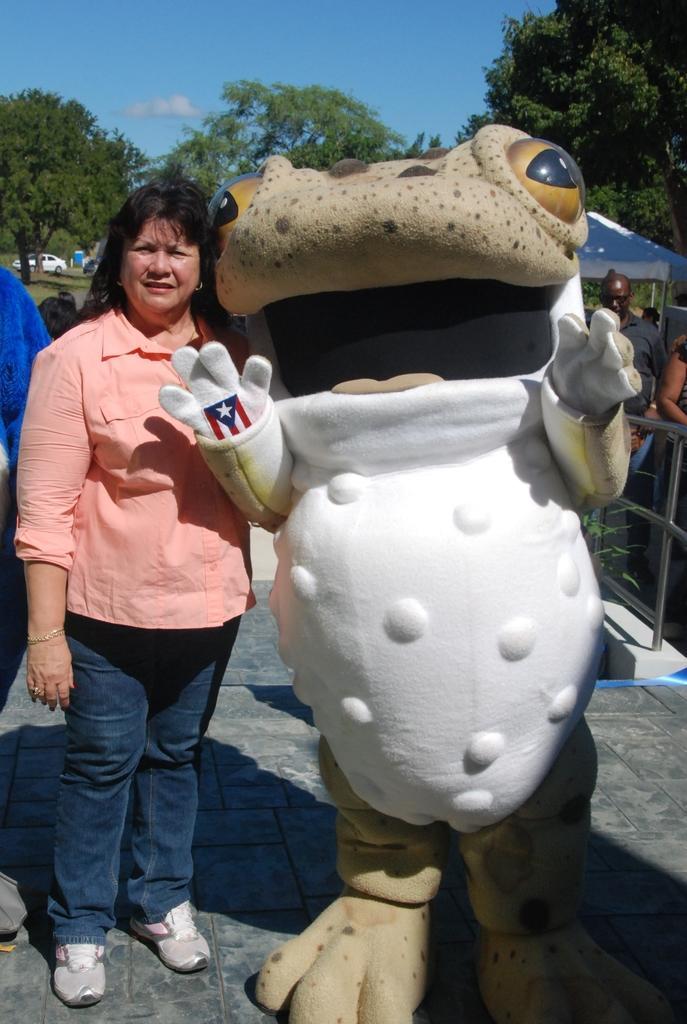Describe this image in one or two sentences. In this picture we can see a woman and a mascot are standing on the floor. In the background we can see some people, fence, tent, car, trees, some objects and the sky. 